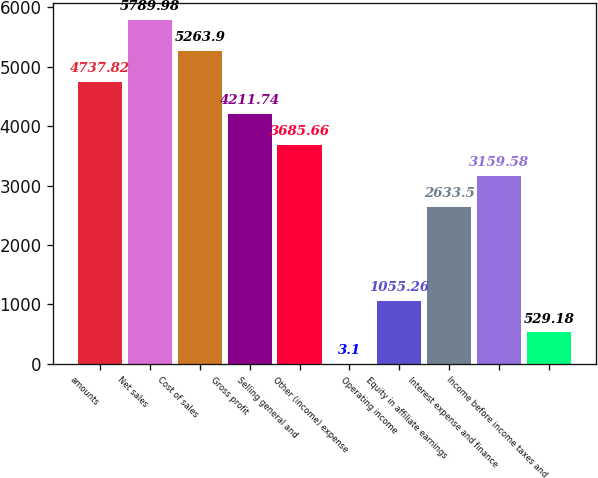Convert chart to OTSL. <chart><loc_0><loc_0><loc_500><loc_500><bar_chart><fcel>amounts<fcel>Net sales<fcel>Cost of sales<fcel>Gross profit<fcel>Selling general and<fcel>Other (income) expense<fcel>Operating income<fcel>Equity in affiliate earnings<fcel>Interest expense and finance<fcel>Income before income taxes and<nl><fcel>4737.82<fcel>5789.98<fcel>5263.9<fcel>4211.74<fcel>3685.66<fcel>3.1<fcel>1055.26<fcel>2633.5<fcel>3159.58<fcel>529.18<nl></chart> 